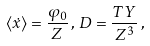Convert formula to latex. <formula><loc_0><loc_0><loc_500><loc_500>\langle \dot { x } \rangle = \frac { \varphi _ { 0 } } { Z } \, , \, D = \frac { T Y } { Z ^ { 3 } } \, ,</formula> 